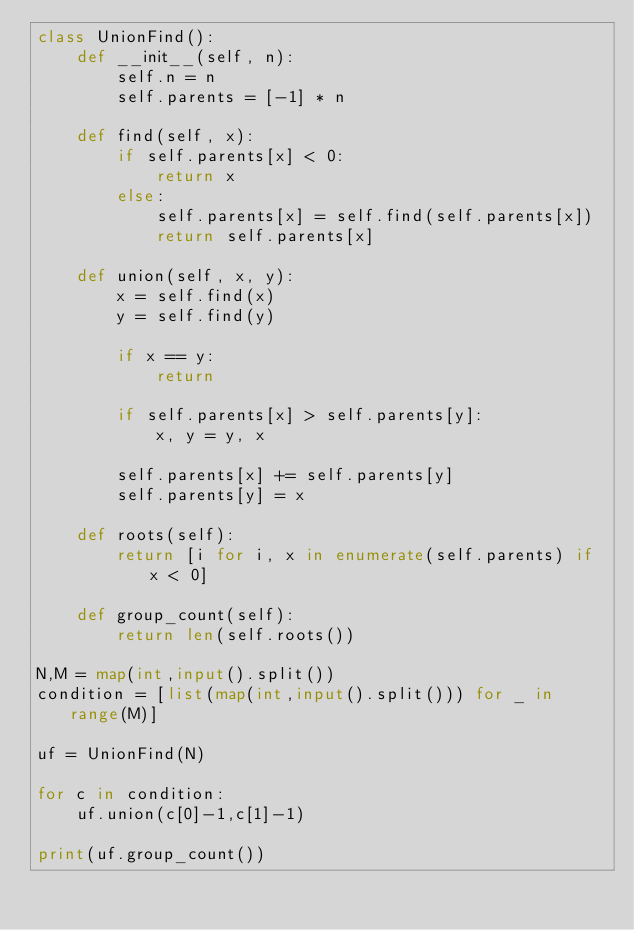Convert code to text. <code><loc_0><loc_0><loc_500><loc_500><_Python_>class UnionFind():
    def __init__(self, n):
        self.n = n
        self.parents = [-1] * n

    def find(self, x):
        if self.parents[x] < 0:
            return x
        else:
            self.parents[x] = self.find(self.parents[x])
            return self.parents[x]

    def union(self, x, y):
        x = self.find(x)
        y = self.find(y)

        if x == y:
            return

        if self.parents[x] > self.parents[y]:
            x, y = y, x

        self.parents[x] += self.parents[y]
        self.parents[y] = x

    def roots(self):
        return [i for i, x in enumerate(self.parents) if x < 0]

    def group_count(self):
        return len(self.roots())

N,M = map(int,input().split())
condition = [list(map(int,input().split())) for _ in range(M)]

uf = UnionFind(N)

for c in condition:
    uf.union(c[0]-1,c[1]-1)

print(uf.group_count())</code> 